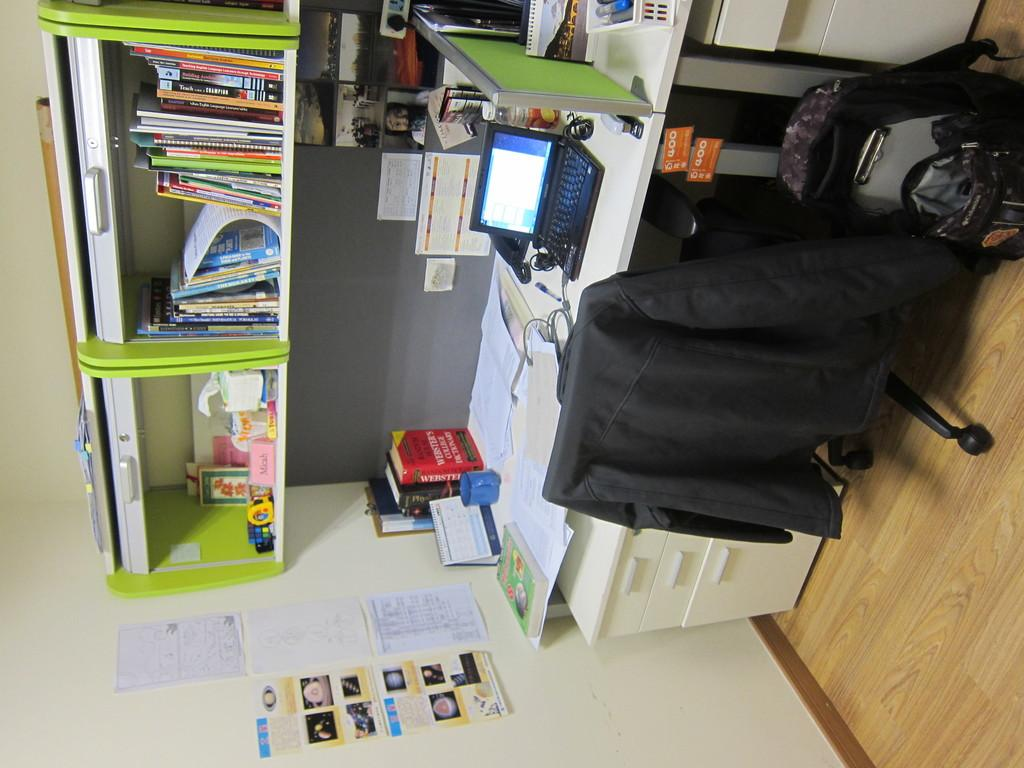<image>
Share a concise interpretation of the image provided. A Webster's College dictionary on a desk with a laptop on it 